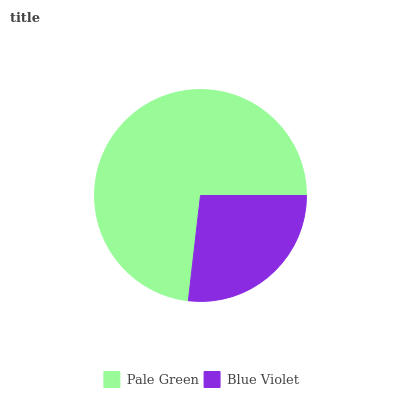Is Blue Violet the minimum?
Answer yes or no. Yes. Is Pale Green the maximum?
Answer yes or no. Yes. Is Blue Violet the maximum?
Answer yes or no. No. Is Pale Green greater than Blue Violet?
Answer yes or no. Yes. Is Blue Violet less than Pale Green?
Answer yes or no. Yes. Is Blue Violet greater than Pale Green?
Answer yes or no. No. Is Pale Green less than Blue Violet?
Answer yes or no. No. Is Pale Green the high median?
Answer yes or no. Yes. Is Blue Violet the low median?
Answer yes or no. Yes. Is Blue Violet the high median?
Answer yes or no. No. Is Pale Green the low median?
Answer yes or no. No. 